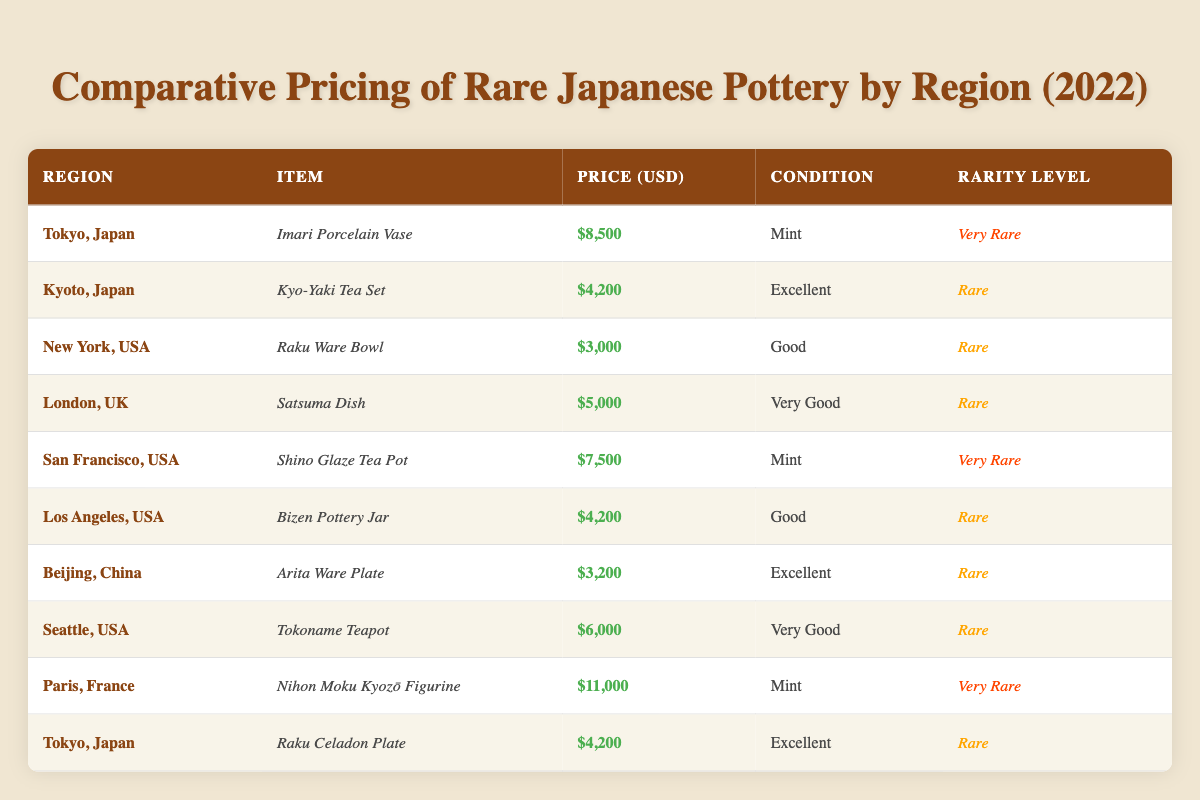What is the price of the Imari Porcelain Vase from Tokyo, Japan? The table lists the item as "Imari Porcelain Vase" located in "Tokyo, Japan" with a price of $8,500.
Answer: $8,500 Which item has the highest price in the table? By comparing all the listed prices, the "Nihon Moku Kyozō Figurine" from Paris, France is the most expensive at $11,000.
Answer: $11,000 How many items listed are categorized as "Very Rare"? The table specifies that there are three items with the "Very Rare" rarity level: the Imari Porcelain Vase, Shino Glaze Tea Pot, and Nihon Moku Kyozō Figurine.
Answer: 3 What is the average price of the listed rare items? The total price of rare items ($4,200 + $3,000 + $4,200 + $5,000 + $4,200 + $3,200 + $6,000) totals $29,900. There are 7 rare items, so the average is $29,900 / 7 = approximately $4,271.43.
Answer: $4,271.43 Which region offers an item in "Excellent" condition for the lowest price? Looking at items in "Excellent" condition, the Arita Ware Plate from Beijing, China is priced at $3,200, which is the lowest for this condition.
Answer: $3,200 Is there any item listed from the USA that is categorized as "Very Rare"? The data shows two "Very Rare" items: the Shino Glaze Tea Pot and the Imari Porcelain Vase, but only the Shino Glaze Tea Pot is from the USA.
Answer: Yes What price difference exists between the highest priced item and the second highest priced item? The highest priced item is the Nihon Moku Kyozō Figurine at $11,000, and the second highest is the Imari Porcelain Vase at $8,500. The price difference is $11,000 - $8,500 = $2,500.
Answer: $2,500 How many ceramic items listed come from Japan? The table shows five items from Japan: Imari Porcelain Vase, Kyo-Yaki Tea Set, Raku Celadon Plate, and two from Tokyo.
Answer: 5 What condition is the Raku Ware Bowl in, and what is its price? The Raku Ware Bowl is in "Good" condition and is priced at $3,000 as per the table details.
Answer: Good, $3,000 Which region's pottery item is the least expensive and what is its price? The Arita Ware Plate from Beijing, China is the least expensive item listed in the table at a price of $3,200.
Answer: $3,200 